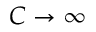Convert formula to latex. <formula><loc_0><loc_0><loc_500><loc_500>C \to \infty</formula> 